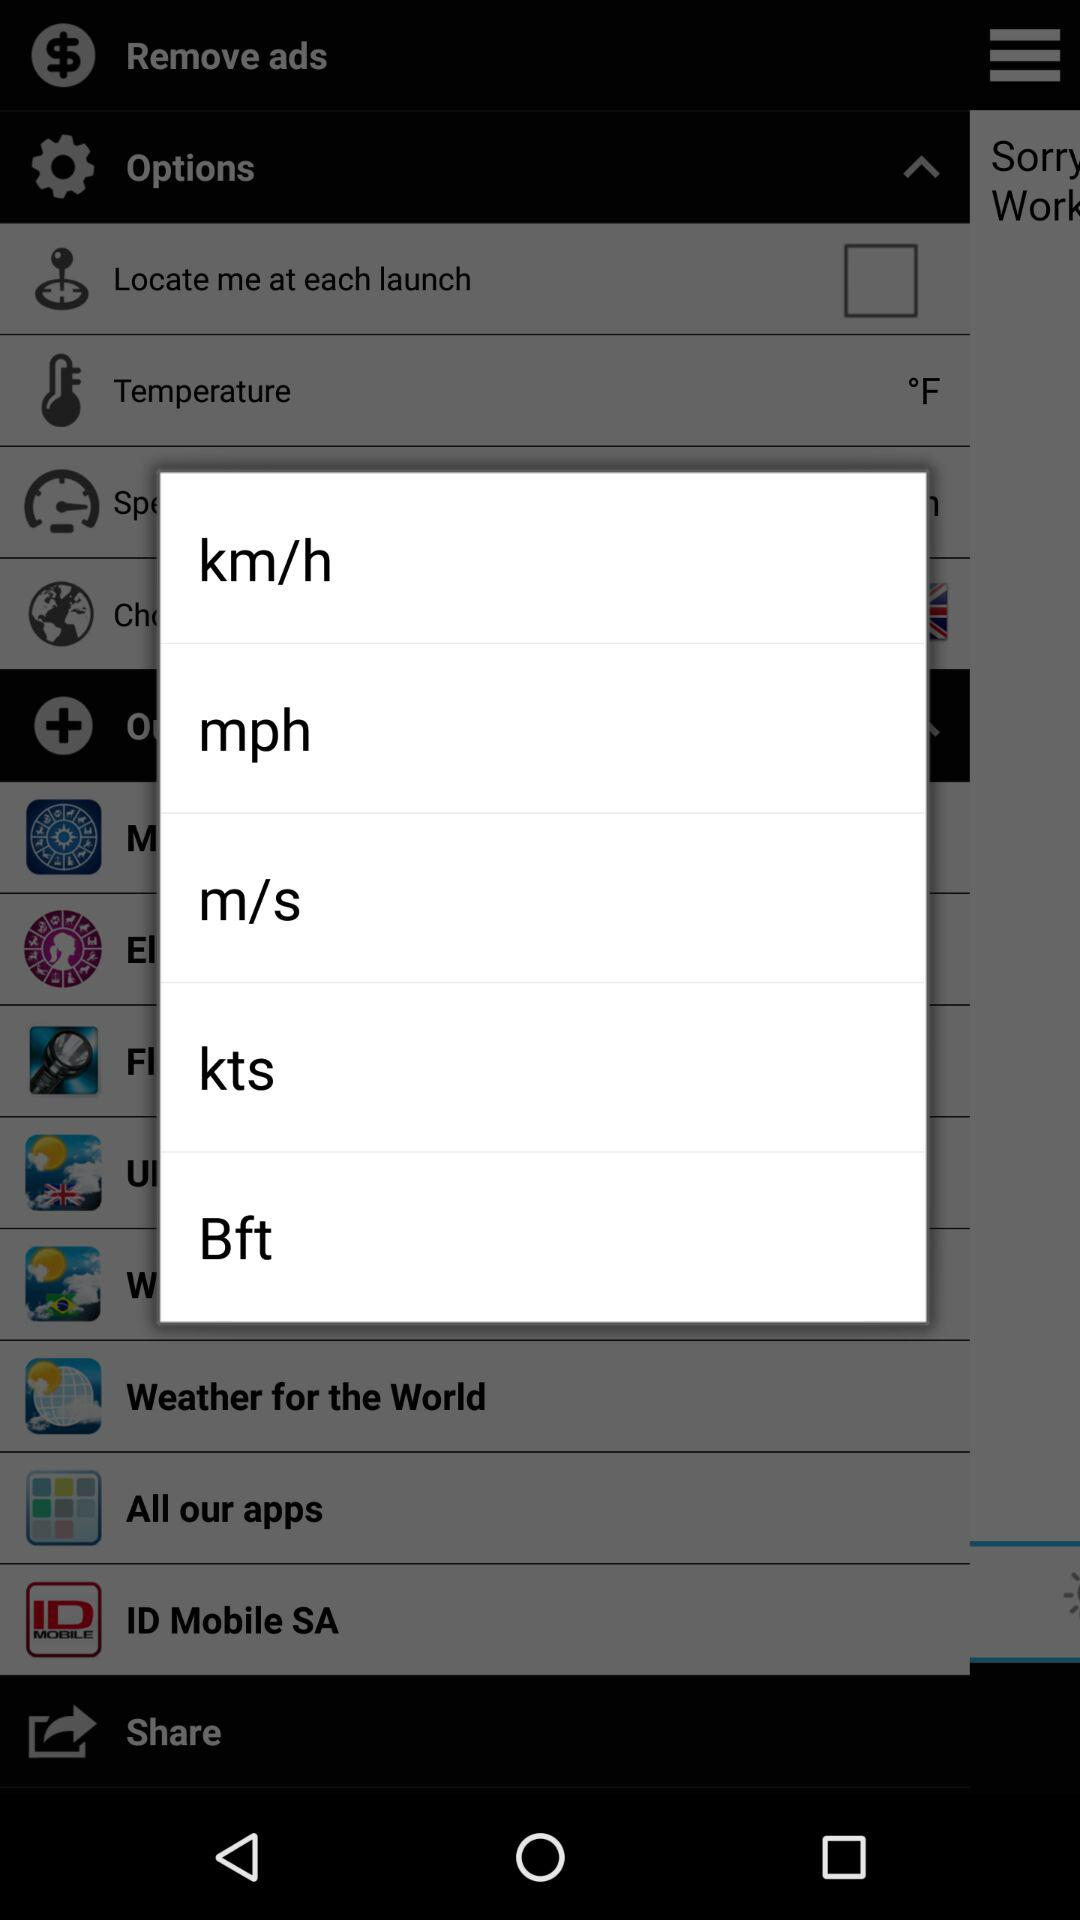What is the status of "Locate me at each launch"? The status is "off". 